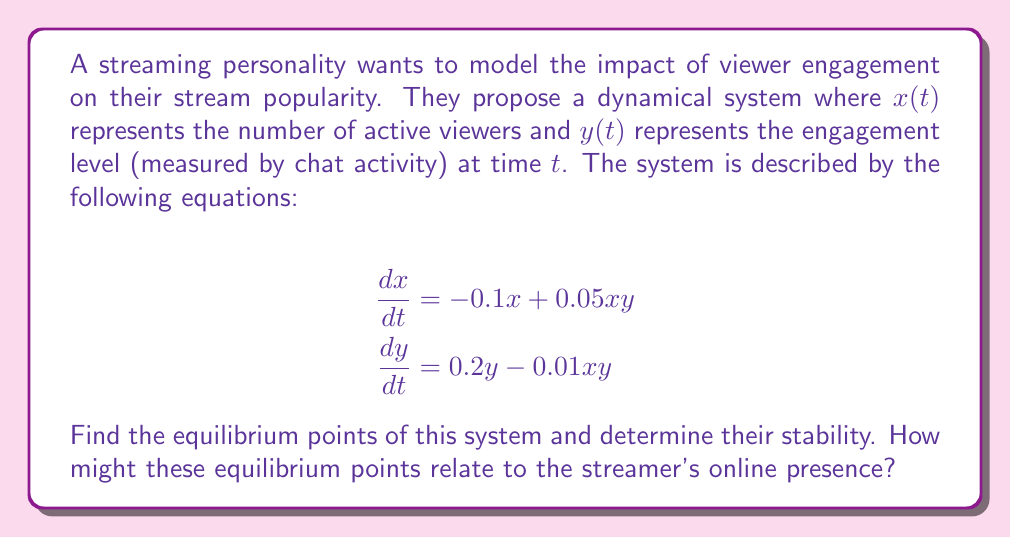Give your solution to this math problem. 1. To find the equilibrium points, we set both equations equal to zero:

   $$-0.1x + 0.05xy = 0$$
   $$0.2y - 0.01xy = 0$$

2. From the first equation:
   $$x(0.05y - 0.1) = 0$$
   This gives us $x = 0$ or $y = 2$

3. From the second equation:
   $$y(0.2 - 0.01x) = 0$$
   This gives us $y = 0$ or $x = 20$

4. Combining these results, we get two equilibrium points:
   $(0, 0)$ and $(20, 2)$

5. To determine stability, we calculate the Jacobian matrix:

   $$J = \begin{bmatrix}
   -0.1 + 0.05y & 0.05x \\
   -0.01y & 0.2 - 0.01x
   \end{bmatrix}$$

6. For $(0, 0)$:
   $$J_{(0,0)} = \begin{bmatrix}
   -0.1 & 0 \\
   0 & 0.2
   \end{bmatrix}$$
   Eigenvalues: $\lambda_1 = -0.1$, $\lambda_2 = 0.2$
   Since one eigenvalue is positive, this is an unstable saddle point.

7. For $(20, 2)$:
   $$J_{(20,2)} = \begin{bmatrix}
   0 & 1 \\
   -0.02 & 0
   \end{bmatrix}$$
   Eigenvalues: $\lambda = \pm \sqrt{-0.02} = \pm 0.1414i$
   Since the real parts are zero, this is a center (neutrally stable).

8. Interpretation:
   - $(0, 0)$ represents no viewers and no engagement, which is unstable.
   - $(20, 2)$ represents a balanced state of 20 active viewers and an engagement level of 2, which is neutrally stable.

The streamer should aim to maintain their stream near the $(20, 2)$ equilibrium point for a consistent online presence.
Answer: Equilibrium points: $(0, 0)$ (unstable saddle) and $(20, 2)$ (neutrally stable center). 